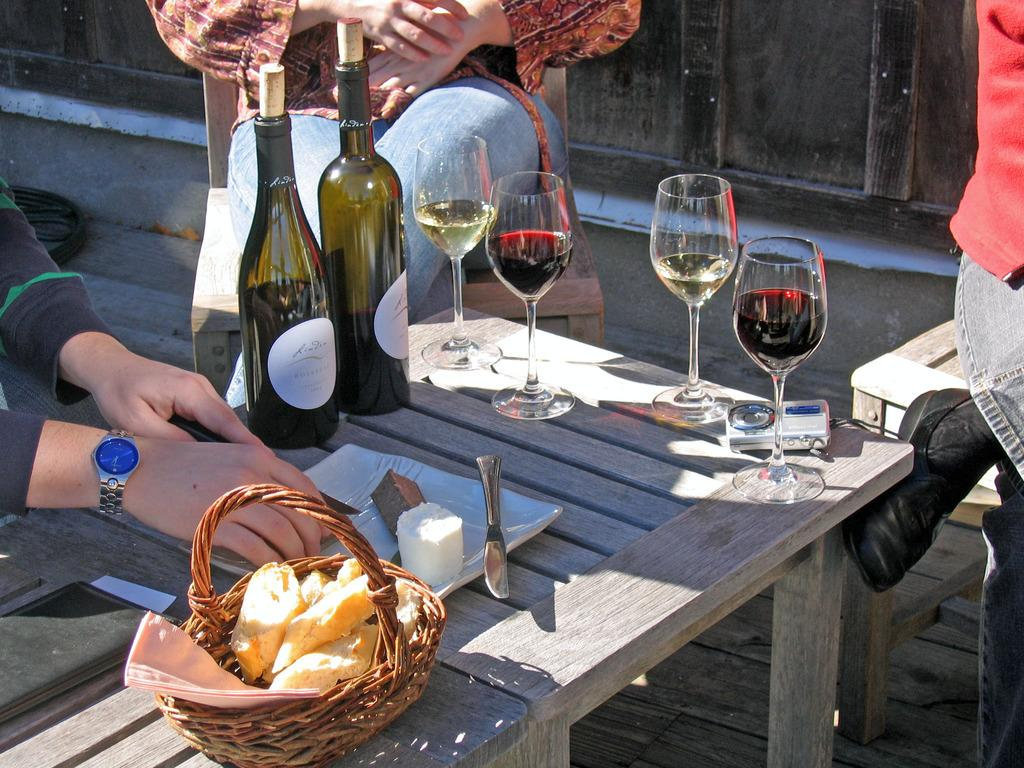What is the main piece of furniture in the image? There is a table in the image. What items related to wine can be seen on the table? There are wine bottles and wine glasses on the table. What other items are on the table? There is a knife and a basket with bread pieces on the table. What is the person holding in the image? The person is holding a paper. What type of waves can be seen crashing on the shore in the image? There are no waves or shore visible in the image; it features a table with various items and a person holding a paper. What kind of flesh is being served on a plate in the image? There is no flesh or plate present in the image; it features a table with wine bottles, glasses, a knife, bread basket, and a person holding a paper. 